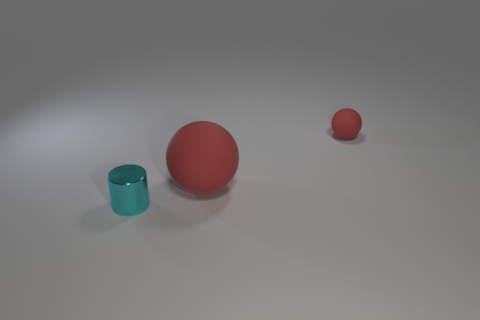Can you describe the spatial arrangement of the objects? Certainly. There are three objects arranged with the large red ball centrally positioned in the foreground. To its left and slightly behind it is the small blue cup, while the tiny red ball is farther to the right and appears to be in the background. 